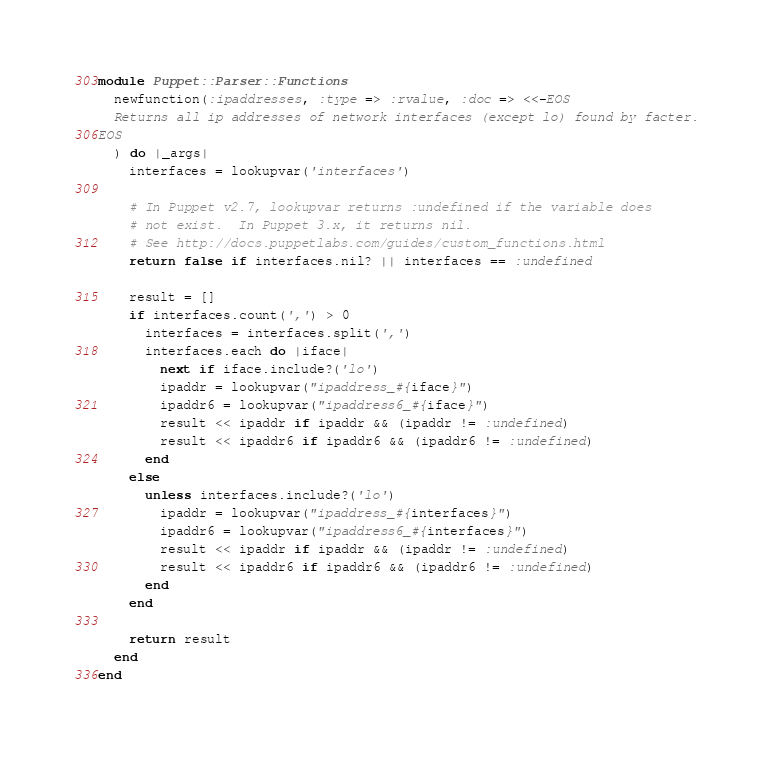Convert code to text. <code><loc_0><loc_0><loc_500><loc_500><_Ruby_>module Puppet::Parser::Functions
  newfunction(:ipaddresses, :type => :rvalue, :doc => <<-EOS
  Returns all ip addresses of network interfaces (except lo) found by facter.
EOS
  ) do |_args|
    interfaces = lookupvar('interfaces')

    # In Puppet v2.7, lookupvar returns :undefined if the variable does
    # not exist.  In Puppet 3.x, it returns nil.
    # See http://docs.puppetlabs.com/guides/custom_functions.html
    return false if interfaces.nil? || interfaces == :undefined

    result = []
    if interfaces.count(',') > 0
      interfaces = interfaces.split(',')
      interfaces.each do |iface|
        next if iface.include?('lo')
        ipaddr = lookupvar("ipaddress_#{iface}")
        ipaddr6 = lookupvar("ipaddress6_#{iface}")
        result << ipaddr if ipaddr && (ipaddr != :undefined)
        result << ipaddr6 if ipaddr6 && (ipaddr6 != :undefined)
      end
    else
      unless interfaces.include?('lo')
        ipaddr = lookupvar("ipaddress_#{interfaces}")
        ipaddr6 = lookupvar("ipaddress6_#{interfaces}")
        result << ipaddr if ipaddr && (ipaddr != :undefined)
        result << ipaddr6 if ipaddr6 && (ipaddr6 != :undefined)
      end
    end

    return result
  end
end
</code> 